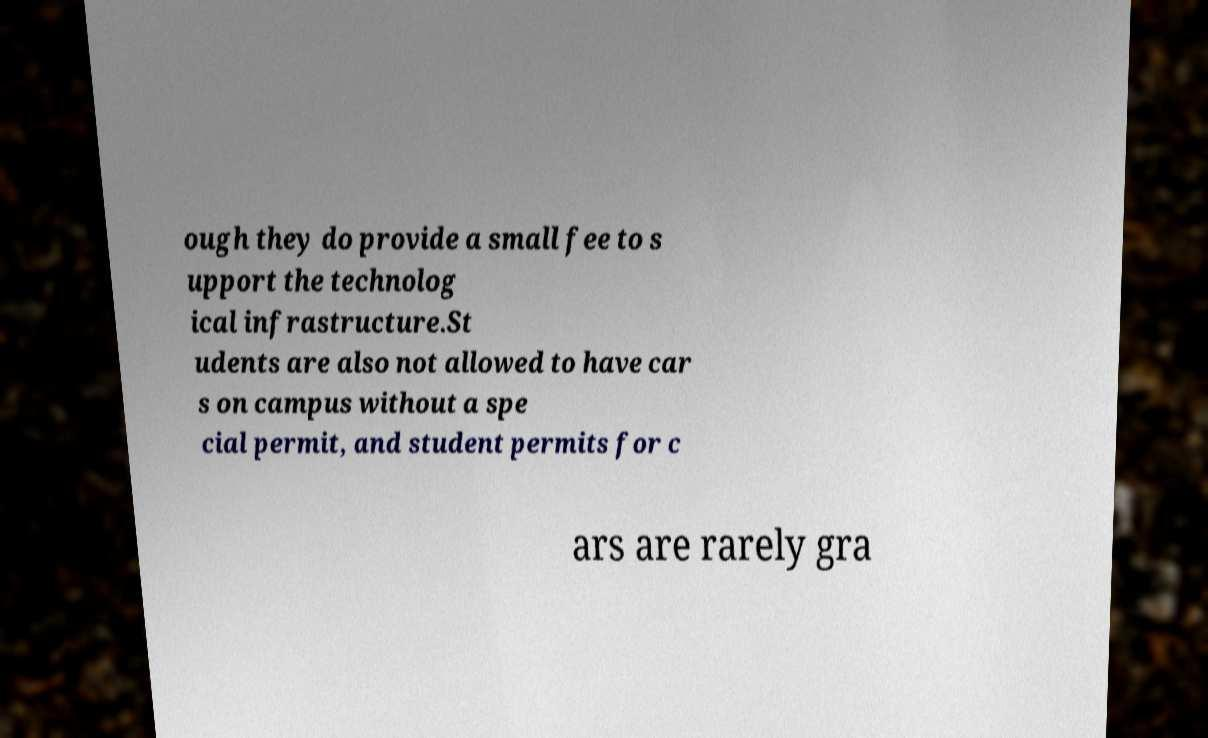Can you accurately transcribe the text from the provided image for me? ough they do provide a small fee to s upport the technolog ical infrastructure.St udents are also not allowed to have car s on campus without a spe cial permit, and student permits for c ars are rarely gra 